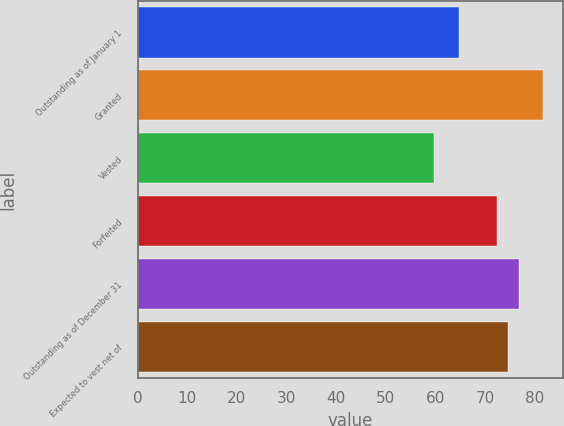Convert chart. <chart><loc_0><loc_0><loc_500><loc_500><bar_chart><fcel>Outstanding as of January 1<fcel>Granted<fcel>Vested<fcel>Forfeited<fcel>Outstanding as of December 31<fcel>Expected to vest net of<nl><fcel>64.75<fcel>81.54<fcel>59.65<fcel>72.36<fcel>76.74<fcel>74.55<nl></chart> 